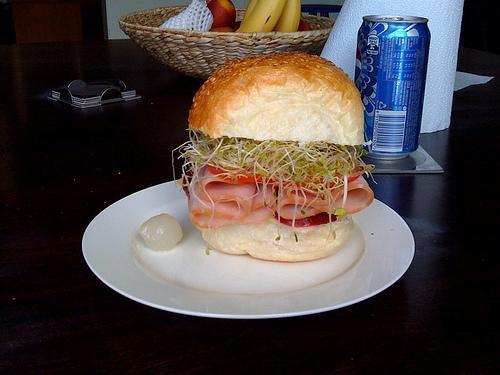How many sandwiches are there?
Give a very brief answer. 1. How many sandwiches are in this photo?
Give a very brief answer. 1. How many people can sit at the table?
Give a very brief answer. 0. 